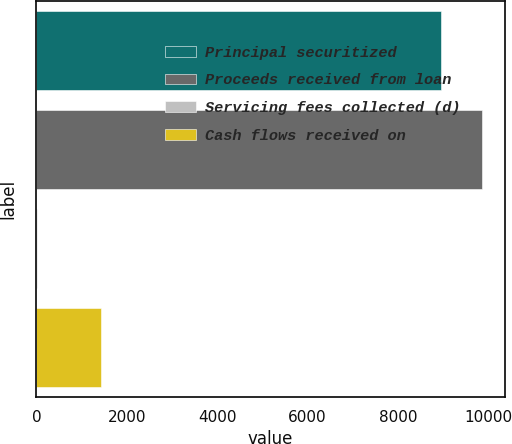<chart> <loc_0><loc_0><loc_500><loc_500><bar_chart><fcel>Principal securitized<fcel>Proceeds received from loan<fcel>Servicing fees collected (d)<fcel>Cash flows received on<nl><fcel>8964<fcel>9873.1<fcel>3<fcel>1441<nl></chart> 